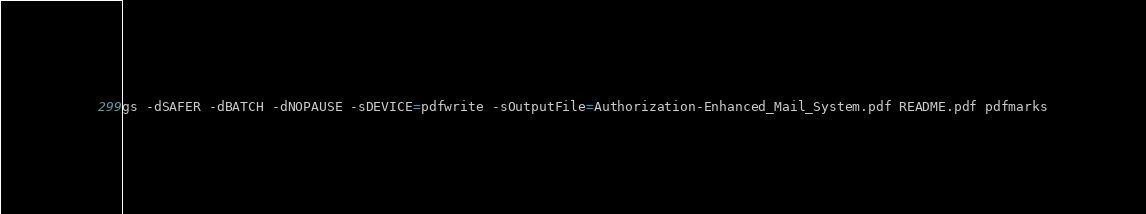Convert code to text. <code><loc_0><loc_0><loc_500><loc_500><_Bash_>gs -dSAFER -dBATCH -dNOPAUSE -sDEVICE=pdfwrite -sOutputFile=Authorization-Enhanced_Mail_System.pdf README.pdf pdfmarks</code> 